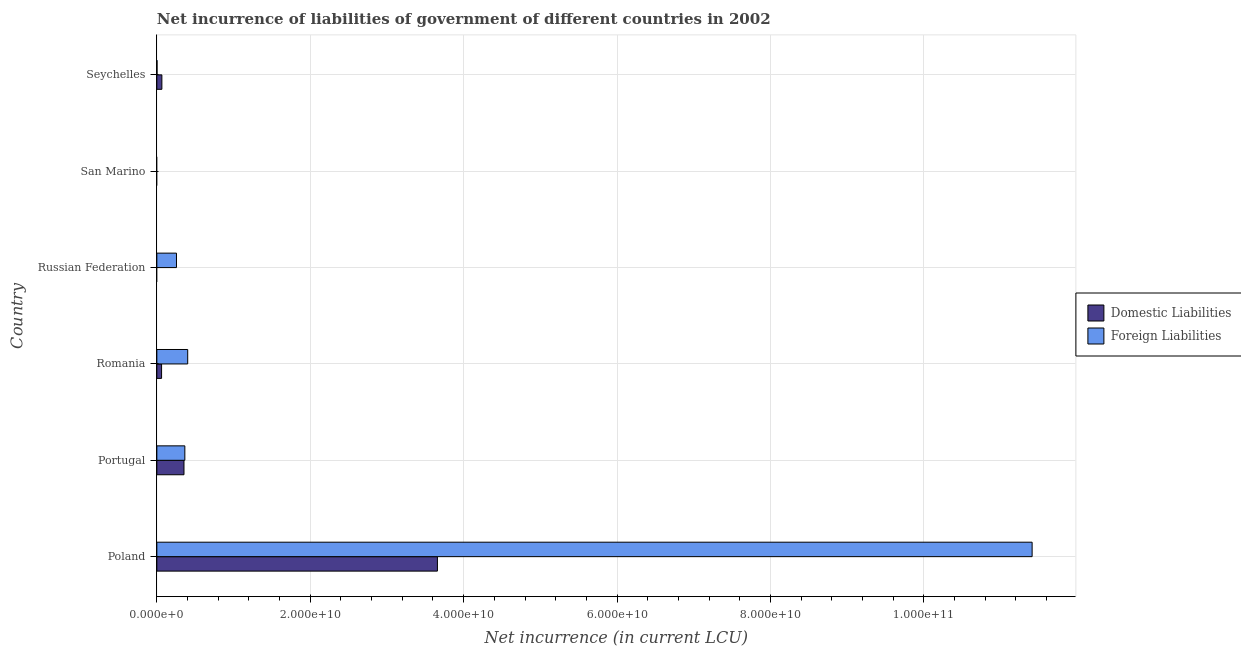How many different coloured bars are there?
Give a very brief answer. 2. How many bars are there on the 2nd tick from the bottom?
Keep it short and to the point. 2. What is the label of the 2nd group of bars from the top?
Provide a succinct answer. San Marino. What is the net incurrence of domestic liabilities in Russian Federation?
Your answer should be compact. 0. Across all countries, what is the maximum net incurrence of domestic liabilities?
Provide a succinct answer. 3.66e+1. Across all countries, what is the minimum net incurrence of foreign liabilities?
Ensure brevity in your answer.  0. In which country was the net incurrence of domestic liabilities maximum?
Keep it short and to the point. Poland. What is the total net incurrence of domestic liabilities in the graph?
Keep it short and to the point. 4.14e+1. What is the difference between the net incurrence of foreign liabilities in Poland and that in Portugal?
Give a very brief answer. 1.10e+11. What is the difference between the net incurrence of domestic liabilities in San Marino and the net incurrence of foreign liabilities in Portugal?
Ensure brevity in your answer.  -3.65e+09. What is the average net incurrence of domestic liabilities per country?
Ensure brevity in your answer.  6.90e+09. What is the difference between the net incurrence of foreign liabilities and net incurrence of domestic liabilities in Poland?
Your response must be concise. 7.75e+1. In how many countries, is the net incurrence of foreign liabilities greater than 12000000000 LCU?
Give a very brief answer. 1. What is the ratio of the net incurrence of foreign liabilities in Romania to that in Russian Federation?
Provide a short and direct response. 1.57. Is the net incurrence of domestic liabilities in Portugal less than that in Romania?
Your answer should be very brief. No. Is the difference between the net incurrence of foreign liabilities in Romania and Seychelles greater than the difference between the net incurrence of domestic liabilities in Romania and Seychelles?
Your answer should be compact. Yes. What is the difference between the highest and the second highest net incurrence of foreign liabilities?
Your answer should be compact. 1.10e+11. What is the difference between the highest and the lowest net incurrence of foreign liabilities?
Offer a terse response. 1.14e+11. Are all the bars in the graph horizontal?
Offer a terse response. Yes. Are the values on the major ticks of X-axis written in scientific E-notation?
Your answer should be compact. Yes. Does the graph contain any zero values?
Keep it short and to the point. Yes. How many legend labels are there?
Your response must be concise. 2. How are the legend labels stacked?
Provide a short and direct response. Vertical. What is the title of the graph?
Ensure brevity in your answer.  Net incurrence of liabilities of government of different countries in 2002. What is the label or title of the X-axis?
Keep it short and to the point. Net incurrence (in current LCU). What is the label or title of the Y-axis?
Offer a very short reply. Country. What is the Net incurrence (in current LCU) of Domestic Liabilities in Poland?
Your answer should be compact. 3.66e+1. What is the Net incurrence (in current LCU) in Foreign Liabilities in Poland?
Offer a very short reply. 1.14e+11. What is the Net incurrence (in current LCU) in Domestic Liabilities in Portugal?
Your answer should be compact. 3.54e+09. What is the Net incurrence (in current LCU) of Foreign Liabilities in Portugal?
Ensure brevity in your answer.  3.65e+09. What is the Net incurrence (in current LCU) of Domestic Liabilities in Romania?
Provide a succinct answer. 6.17e+08. What is the Net incurrence (in current LCU) in Foreign Liabilities in Romania?
Your answer should be very brief. 4.02e+09. What is the Net incurrence (in current LCU) in Domestic Liabilities in Russian Federation?
Provide a succinct answer. 0. What is the Net incurrence (in current LCU) of Foreign Liabilities in Russian Federation?
Provide a short and direct response. 2.56e+09. What is the Net incurrence (in current LCU) of Domestic Liabilities in San Marino?
Offer a terse response. 0. What is the Net incurrence (in current LCU) in Domestic Liabilities in Seychelles?
Offer a terse response. 6.56e+08. What is the Net incurrence (in current LCU) in Foreign Liabilities in Seychelles?
Give a very brief answer. 2.32e+07. Across all countries, what is the maximum Net incurrence (in current LCU) of Domestic Liabilities?
Make the answer very short. 3.66e+1. Across all countries, what is the maximum Net incurrence (in current LCU) in Foreign Liabilities?
Ensure brevity in your answer.  1.14e+11. Across all countries, what is the minimum Net incurrence (in current LCU) of Foreign Liabilities?
Provide a short and direct response. 0. What is the total Net incurrence (in current LCU) of Domestic Liabilities in the graph?
Provide a succinct answer. 4.14e+1. What is the total Net incurrence (in current LCU) in Foreign Liabilities in the graph?
Provide a succinct answer. 1.24e+11. What is the difference between the Net incurrence (in current LCU) of Domestic Liabilities in Poland and that in Portugal?
Make the answer very short. 3.30e+1. What is the difference between the Net incurrence (in current LCU) of Foreign Liabilities in Poland and that in Portugal?
Your response must be concise. 1.10e+11. What is the difference between the Net incurrence (in current LCU) of Domestic Liabilities in Poland and that in Romania?
Your answer should be compact. 3.60e+1. What is the difference between the Net incurrence (in current LCU) in Foreign Liabilities in Poland and that in Romania?
Offer a terse response. 1.10e+11. What is the difference between the Net incurrence (in current LCU) of Foreign Liabilities in Poland and that in Russian Federation?
Your answer should be compact. 1.12e+11. What is the difference between the Net incurrence (in current LCU) in Domestic Liabilities in Poland and that in Seychelles?
Offer a very short reply. 3.59e+1. What is the difference between the Net incurrence (in current LCU) in Foreign Liabilities in Poland and that in Seychelles?
Your answer should be very brief. 1.14e+11. What is the difference between the Net incurrence (in current LCU) in Domestic Liabilities in Portugal and that in Romania?
Provide a short and direct response. 2.92e+09. What is the difference between the Net incurrence (in current LCU) in Foreign Liabilities in Portugal and that in Romania?
Make the answer very short. -3.74e+08. What is the difference between the Net incurrence (in current LCU) of Foreign Liabilities in Portugal and that in Russian Federation?
Offer a terse response. 1.09e+09. What is the difference between the Net incurrence (in current LCU) of Domestic Liabilities in Portugal and that in Seychelles?
Your answer should be very brief. 2.88e+09. What is the difference between the Net incurrence (in current LCU) of Foreign Liabilities in Portugal and that in Seychelles?
Give a very brief answer. 3.63e+09. What is the difference between the Net incurrence (in current LCU) in Foreign Liabilities in Romania and that in Russian Federation?
Make the answer very short. 1.46e+09. What is the difference between the Net incurrence (in current LCU) in Domestic Liabilities in Romania and that in Seychelles?
Give a very brief answer. -3.91e+07. What is the difference between the Net incurrence (in current LCU) in Foreign Liabilities in Romania and that in Seychelles?
Make the answer very short. 4.00e+09. What is the difference between the Net incurrence (in current LCU) of Foreign Liabilities in Russian Federation and that in Seychelles?
Your answer should be compact. 2.54e+09. What is the difference between the Net incurrence (in current LCU) of Domestic Liabilities in Poland and the Net incurrence (in current LCU) of Foreign Liabilities in Portugal?
Keep it short and to the point. 3.29e+1. What is the difference between the Net incurrence (in current LCU) in Domestic Liabilities in Poland and the Net incurrence (in current LCU) in Foreign Liabilities in Romania?
Offer a very short reply. 3.26e+1. What is the difference between the Net incurrence (in current LCU) of Domestic Liabilities in Poland and the Net incurrence (in current LCU) of Foreign Liabilities in Russian Federation?
Provide a succinct answer. 3.40e+1. What is the difference between the Net incurrence (in current LCU) of Domestic Liabilities in Poland and the Net incurrence (in current LCU) of Foreign Liabilities in Seychelles?
Your answer should be compact. 3.66e+1. What is the difference between the Net incurrence (in current LCU) in Domestic Liabilities in Portugal and the Net incurrence (in current LCU) in Foreign Liabilities in Romania?
Your answer should be very brief. -4.85e+08. What is the difference between the Net incurrence (in current LCU) in Domestic Liabilities in Portugal and the Net incurrence (in current LCU) in Foreign Liabilities in Russian Federation?
Provide a succinct answer. 9.79e+08. What is the difference between the Net incurrence (in current LCU) in Domestic Liabilities in Portugal and the Net incurrence (in current LCU) in Foreign Liabilities in Seychelles?
Provide a succinct answer. 3.52e+09. What is the difference between the Net incurrence (in current LCU) in Domestic Liabilities in Romania and the Net incurrence (in current LCU) in Foreign Liabilities in Russian Federation?
Your answer should be very brief. -1.94e+09. What is the difference between the Net incurrence (in current LCU) in Domestic Liabilities in Romania and the Net incurrence (in current LCU) in Foreign Liabilities in Seychelles?
Keep it short and to the point. 5.94e+08. What is the average Net incurrence (in current LCU) of Domestic Liabilities per country?
Give a very brief answer. 6.90e+09. What is the average Net incurrence (in current LCU) in Foreign Liabilities per country?
Make the answer very short. 2.07e+1. What is the difference between the Net incurrence (in current LCU) in Domestic Liabilities and Net incurrence (in current LCU) in Foreign Liabilities in Poland?
Make the answer very short. -7.75e+1. What is the difference between the Net incurrence (in current LCU) of Domestic Liabilities and Net incurrence (in current LCU) of Foreign Liabilities in Portugal?
Provide a short and direct response. -1.10e+08. What is the difference between the Net incurrence (in current LCU) of Domestic Liabilities and Net incurrence (in current LCU) of Foreign Liabilities in Romania?
Provide a short and direct response. -3.41e+09. What is the difference between the Net incurrence (in current LCU) in Domestic Liabilities and Net incurrence (in current LCU) in Foreign Liabilities in Seychelles?
Give a very brief answer. 6.33e+08. What is the ratio of the Net incurrence (in current LCU) in Domestic Liabilities in Poland to that in Portugal?
Provide a succinct answer. 10.34. What is the ratio of the Net incurrence (in current LCU) in Foreign Liabilities in Poland to that in Portugal?
Keep it short and to the point. 31.27. What is the ratio of the Net incurrence (in current LCU) of Domestic Liabilities in Poland to that in Romania?
Keep it short and to the point. 59.29. What is the ratio of the Net incurrence (in current LCU) in Foreign Liabilities in Poland to that in Romania?
Your answer should be compact. 28.36. What is the ratio of the Net incurrence (in current LCU) in Foreign Liabilities in Poland to that in Russian Federation?
Provide a succinct answer. 44.58. What is the ratio of the Net incurrence (in current LCU) of Domestic Liabilities in Poland to that in Seychelles?
Offer a very short reply. 55.76. What is the ratio of the Net incurrence (in current LCU) in Foreign Liabilities in Poland to that in Seychelles?
Your answer should be very brief. 4926.51. What is the ratio of the Net incurrence (in current LCU) of Domestic Liabilities in Portugal to that in Romania?
Provide a short and direct response. 5.74. What is the ratio of the Net incurrence (in current LCU) of Foreign Liabilities in Portugal to that in Romania?
Provide a succinct answer. 0.91. What is the ratio of the Net incurrence (in current LCU) of Foreign Liabilities in Portugal to that in Russian Federation?
Give a very brief answer. 1.43. What is the ratio of the Net incurrence (in current LCU) in Domestic Liabilities in Portugal to that in Seychelles?
Your response must be concise. 5.39. What is the ratio of the Net incurrence (in current LCU) of Foreign Liabilities in Portugal to that in Seychelles?
Offer a very short reply. 157.54. What is the ratio of the Net incurrence (in current LCU) in Foreign Liabilities in Romania to that in Russian Federation?
Offer a terse response. 1.57. What is the ratio of the Net incurrence (in current LCU) of Domestic Liabilities in Romania to that in Seychelles?
Offer a terse response. 0.94. What is the ratio of the Net incurrence (in current LCU) in Foreign Liabilities in Romania to that in Seychelles?
Your answer should be very brief. 173.69. What is the ratio of the Net incurrence (in current LCU) in Foreign Liabilities in Russian Federation to that in Seychelles?
Give a very brief answer. 110.5. What is the difference between the highest and the second highest Net incurrence (in current LCU) of Domestic Liabilities?
Your response must be concise. 3.30e+1. What is the difference between the highest and the second highest Net incurrence (in current LCU) in Foreign Liabilities?
Your answer should be very brief. 1.10e+11. What is the difference between the highest and the lowest Net incurrence (in current LCU) in Domestic Liabilities?
Provide a short and direct response. 3.66e+1. What is the difference between the highest and the lowest Net incurrence (in current LCU) in Foreign Liabilities?
Provide a succinct answer. 1.14e+11. 